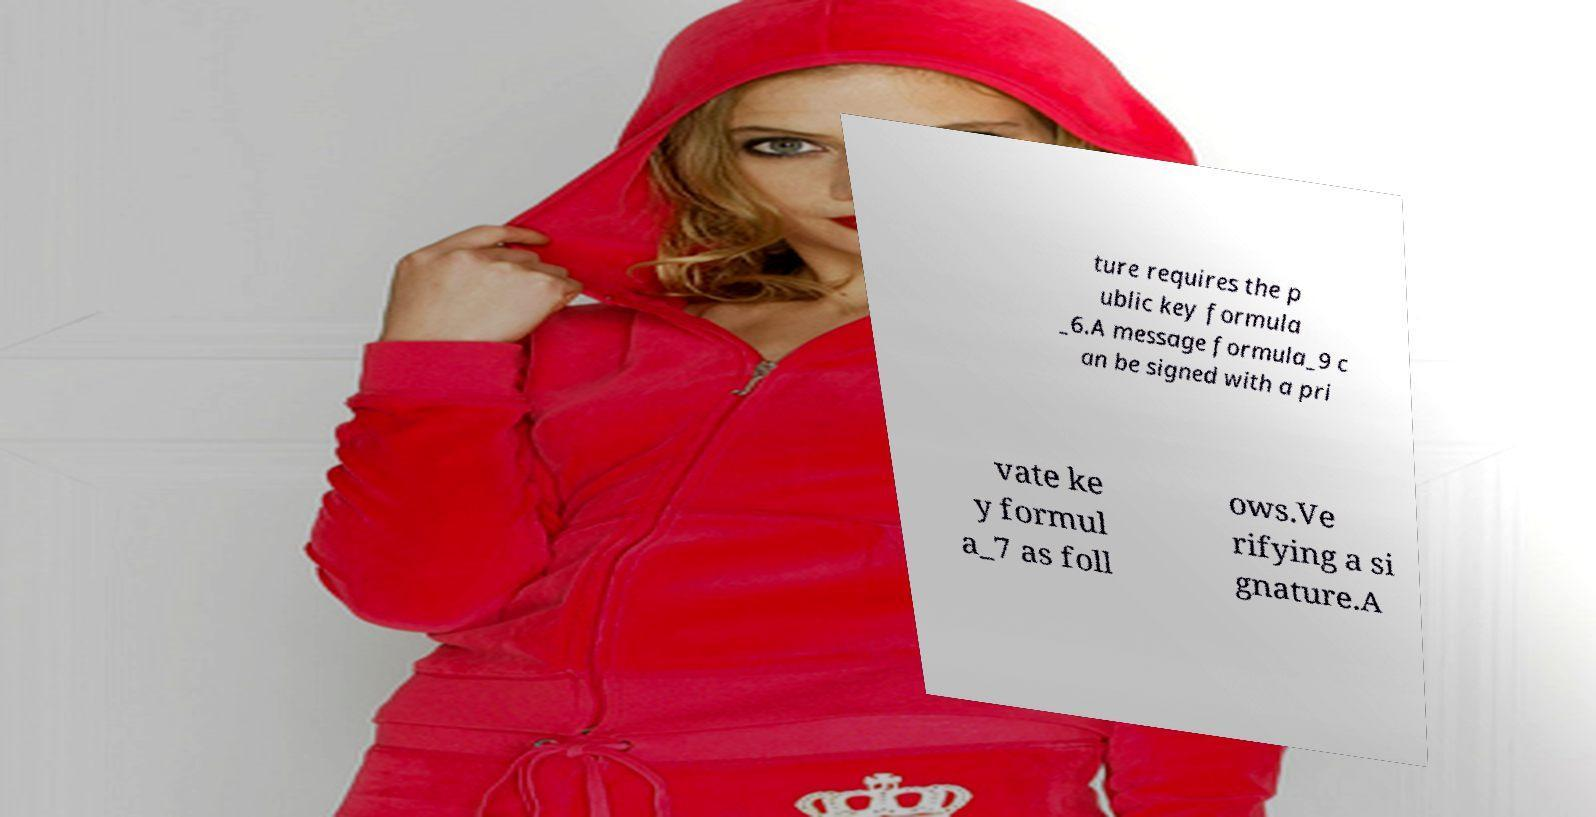Can you accurately transcribe the text from the provided image for me? ture requires the p ublic key formula _6.A message formula_9 c an be signed with a pri vate ke y formul a_7 as foll ows.Ve rifying a si gnature.A 